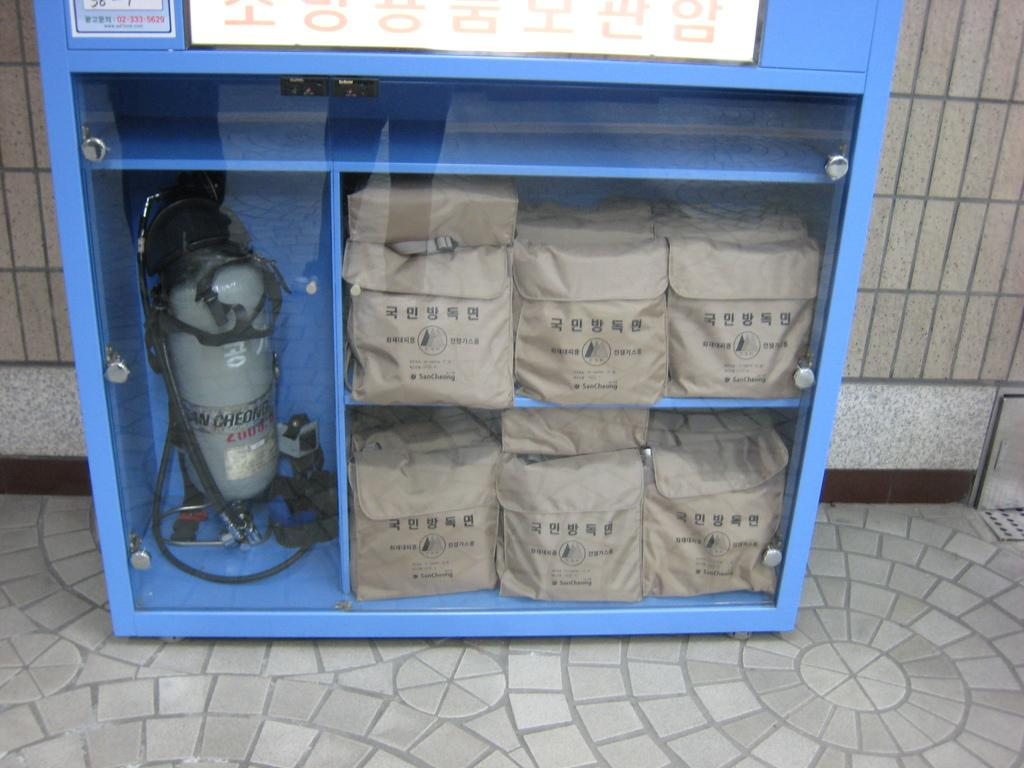What is the main object in the center of the image? There is a cupboard in the center of the image. What can be found inside the cupboard? There are bags and a cylinder in the cupboard. What is visible in the background of the image? There is a wall in the background of the image. How many sisters are playing with the pail in the image? There is no pail or sisters present in the image. 